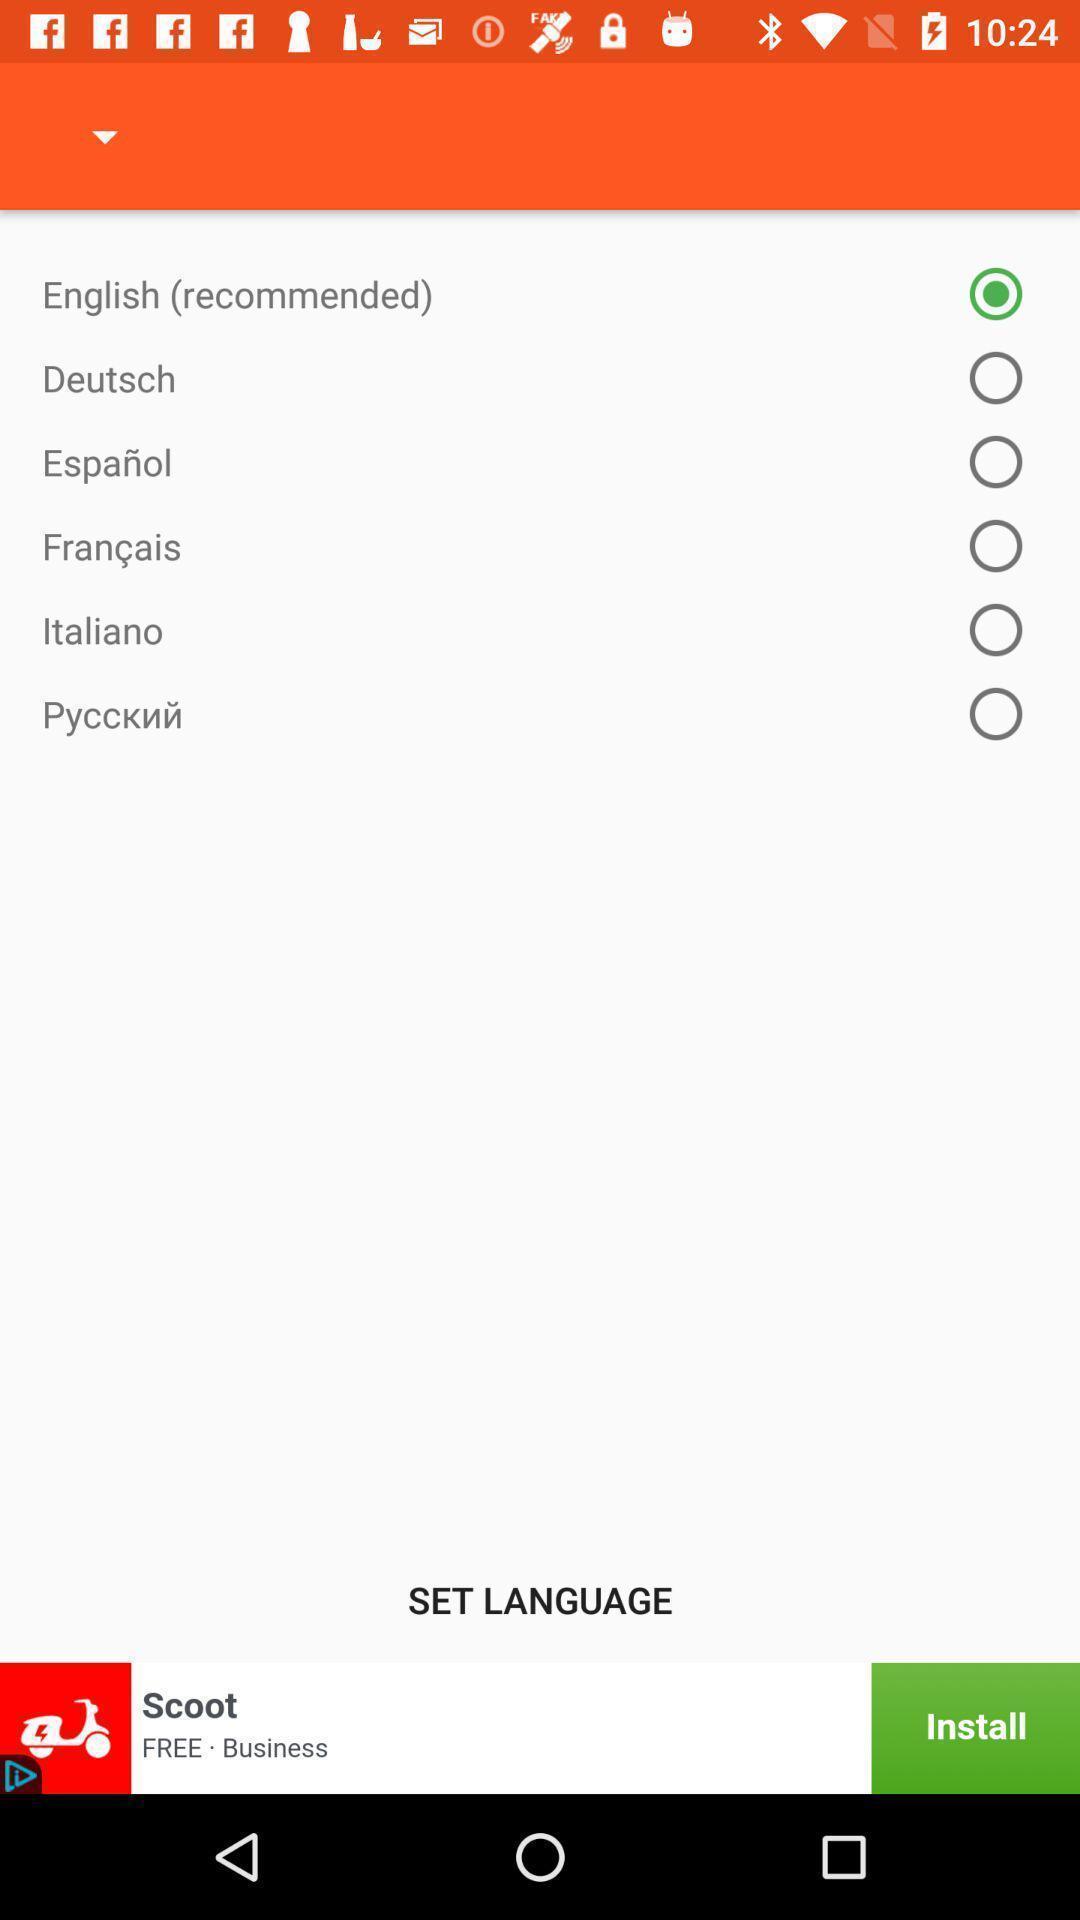Tell me what you see in this picture. Page showing language selection options. 